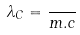<formula> <loc_0><loc_0><loc_500><loc_500>\lambda _ { C } = \frac { } { m . c }</formula> 